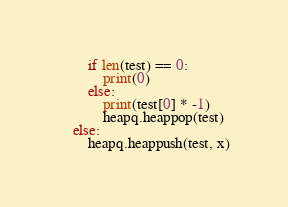Convert code to text. <code><loc_0><loc_0><loc_500><loc_500><_Python_>        if len(test) == 0:
            print(0)
        else:
            print(test[0] * -1)
            heapq.heappop(test)
    else:
        heapq.heappush(test, x)</code> 